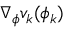Convert formula to latex. <formula><loc_0><loc_0><loc_500><loc_500>\nabla _ { \phi } v _ { k } ( \phi _ { k } )</formula> 